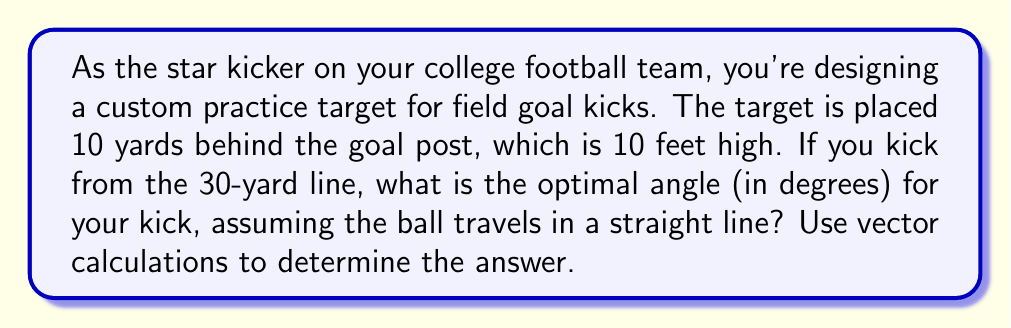Can you solve this math problem? Let's approach this step-by-step using vectors:

1) First, let's define our coordinate system:
   - x-axis: along the ground from the kicking point to the goal post
   - y-axis: vertical height

2) We can represent the kick as a vector from the kicking point to the target:
   $$\vec{v} = \langle x, y \rangle$$

3) We know the following:
   - Distance from kick to goal post: 30 yards
   - Distance from goal post to target: 10 yards
   - Total horizontal distance (x): 40 yards = 120 feet
   - Height of target (y): 10 feet

4) Our vector $\vec{v}$ is therefore:
   $$\vec{v} = \langle 120, 10 \rangle$$

5) To find the angle, we can use the arctangent function:
   $$\theta = \arctan(\frac{y}{x}) = \arctan(\frac{10}{120})$$

6) Calculate:
   $$\theta = \arctan(\frac{1}{12}) \approx 0.0831 \text{ radians}$$

7) Convert to degrees:
   $$\theta \approx 0.0831 \times \frac{180}{\pi} \approx 4.76°$$

Therefore, the optimal angle for the kick is approximately 4.76 degrees.
Answer: $4.76°$ 